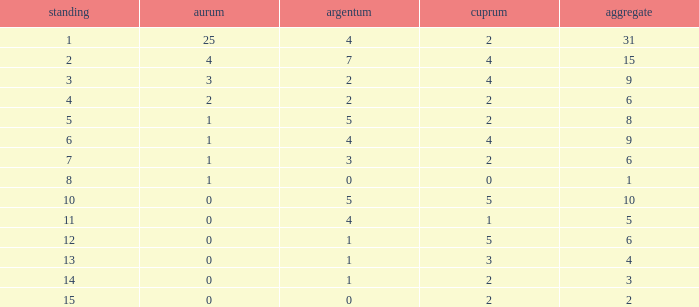What is the highest rank of the medal total less than 15, more than 2 bronzes, 0 gold and 1 silver? 13.0. 